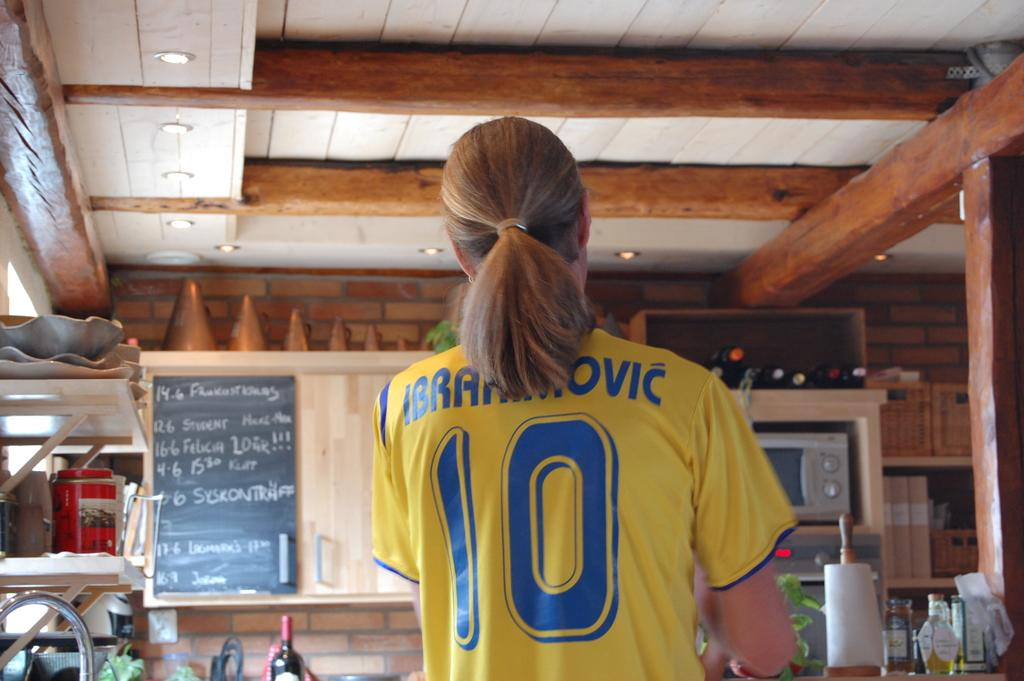<image>
Offer a succinct explanation of the picture presented. a person with a ponytail wearing a shirt that says the number 10 on it 